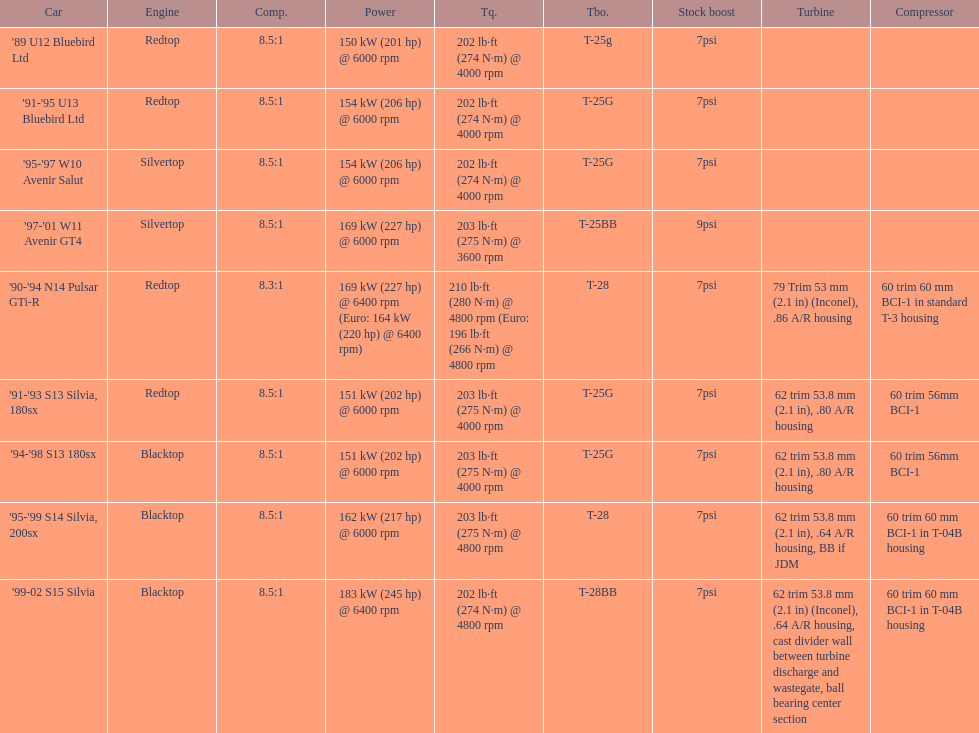Which engine has the smallest compression rate? '90-'94 N14 Pulsar GTi-R. 